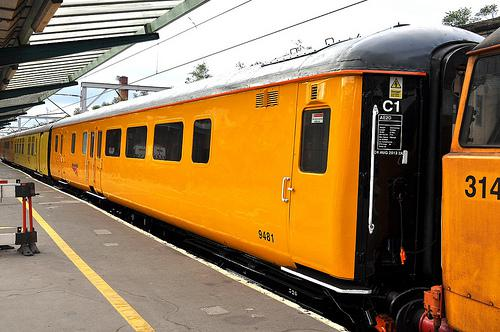Question: why is this photo illuminated?
Choices:
A. Candles.
B. Overhead light.
C. Spotlight.
D. Sunlight.
Answer with the letter. Answer: D Question: what color is the ground?
Choices:
A. Teal.
B. Purple.
C. Gray.
D. Neon.
Answer with the letter. Answer: C Question: what color is the sky?
Choices:
A. Teal.
B. Purple.
C. Light gray.
D. Neon.
Answer with the letter. Answer: C Question: where was this photo taken?
Choices:
A. At the bus stop.
B. At the airport.
C. At the subway.
D. At the train station.
Answer with the letter. Answer: D 